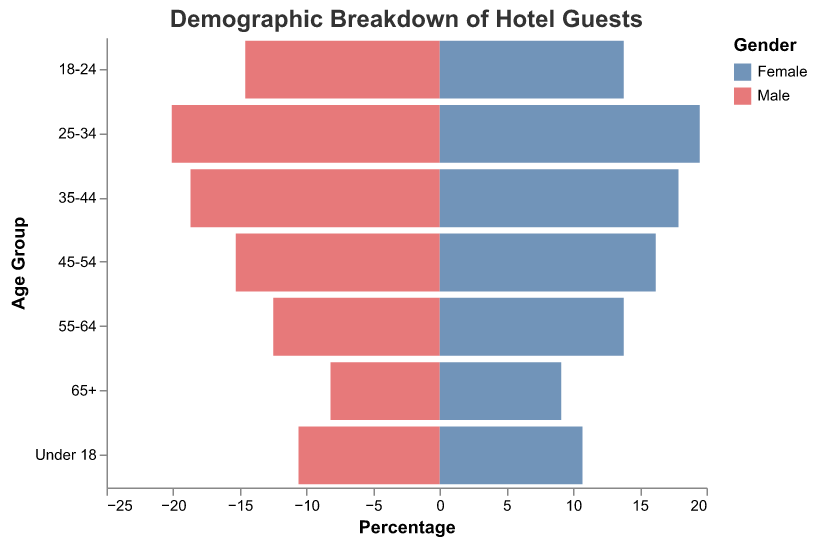How many age groups are shown in the figure? By counting the distinct age groups listed along the y-axis, we see there are seven age groups.
Answer: 7 Which gender has a higher percentage of guests in the 25-34 age group? By comparing the height of the bars for the 25-34 age group, the bar for males is slightly higher than that for females.
Answer: Male What is the total percentage of guests in the 18-24 age group? Adding the percentage values for both genders in the 18-24 age group: Male (14.6%) + Female (13.8%) = 28.4%.
Answer: 28.4% In which age group is the percentage difference between males and females the largest? Calculating the absolute difference in percentages for each age group, the 55-64 age group has the largest difference:
Answer: 55-64 What is the average percentage of male guests across all age groups? Summing the percentage values for males across all age groups and then dividing by the number of age groups: (8.2 + 12.5 + 15.3 + 18.7 + 20.1 + 14.6 + 10.6) / 7 = 14.29%.
Answer: 14.29% How is the percentage of female guests distributed among age groups? Observing the distribution of bar lengths on the female side, the percentages distribute as follows: 65+ (9.1%), 55-64 (13.8%), 45-54 (16.2%), 35-44 (17.9%), 25-34 (19.5%), 18-24 (13.8%), Under 18 (10.7%).
Answer: 9.1%, 13.8%, 16.2%, 17.9%, 19.5%, 13.8%, 10.7% What is the combined percentage of male and female guests in the under 18 age group? Adding the male and female percentages in the under 18 age group: 10.6% + 10.7% = 21.3%
Answer: 21.3% For which age group is the percentage of male guests the closest to the percentage of female guests? Finding the age group with the smallest percentage difference between genders, the under 18 group has the closest values with a difference of 0.1%.
Answer: Under 18 In the 45-54 age group, how does the percentage of male guests compare to female guests? Comparing the bars for the 45-54 age group, the percentage of female guests (16.2%) is higher than that of male guests (15.3%).
Answer: Female guests have a higher percentage Which gender has a higher percentage of guests overall, and in which age group is this difference most pronounced? Summing the percentages for each gender across all age groups reveals that females have a higher overall percentage, and the biggest difference is in the 55-64 age group where females lead by 1.3%.
Answer: Female, 55-64 